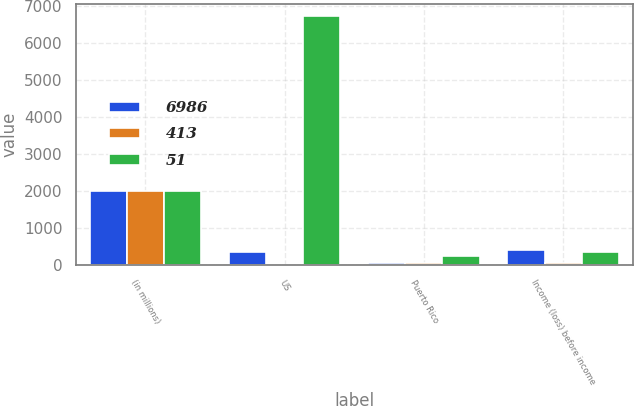Convert chart to OTSL. <chart><loc_0><loc_0><loc_500><loc_500><stacked_bar_chart><ecel><fcel>(in millions)<fcel>US<fcel>Puerto Rico<fcel>Income (loss) before income<nl><fcel>6986<fcel>2014<fcel>347<fcel>66<fcel>413<nl><fcel>413<fcel>2013<fcel>5<fcel>56<fcel>51<nl><fcel>51<fcel>2012<fcel>6739<fcel>247<fcel>347<nl></chart> 